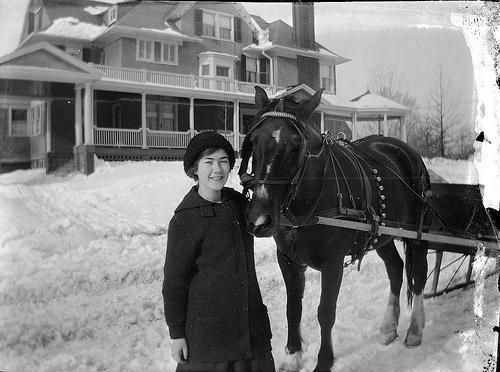How many people are there?
Give a very brief answer. 1. 